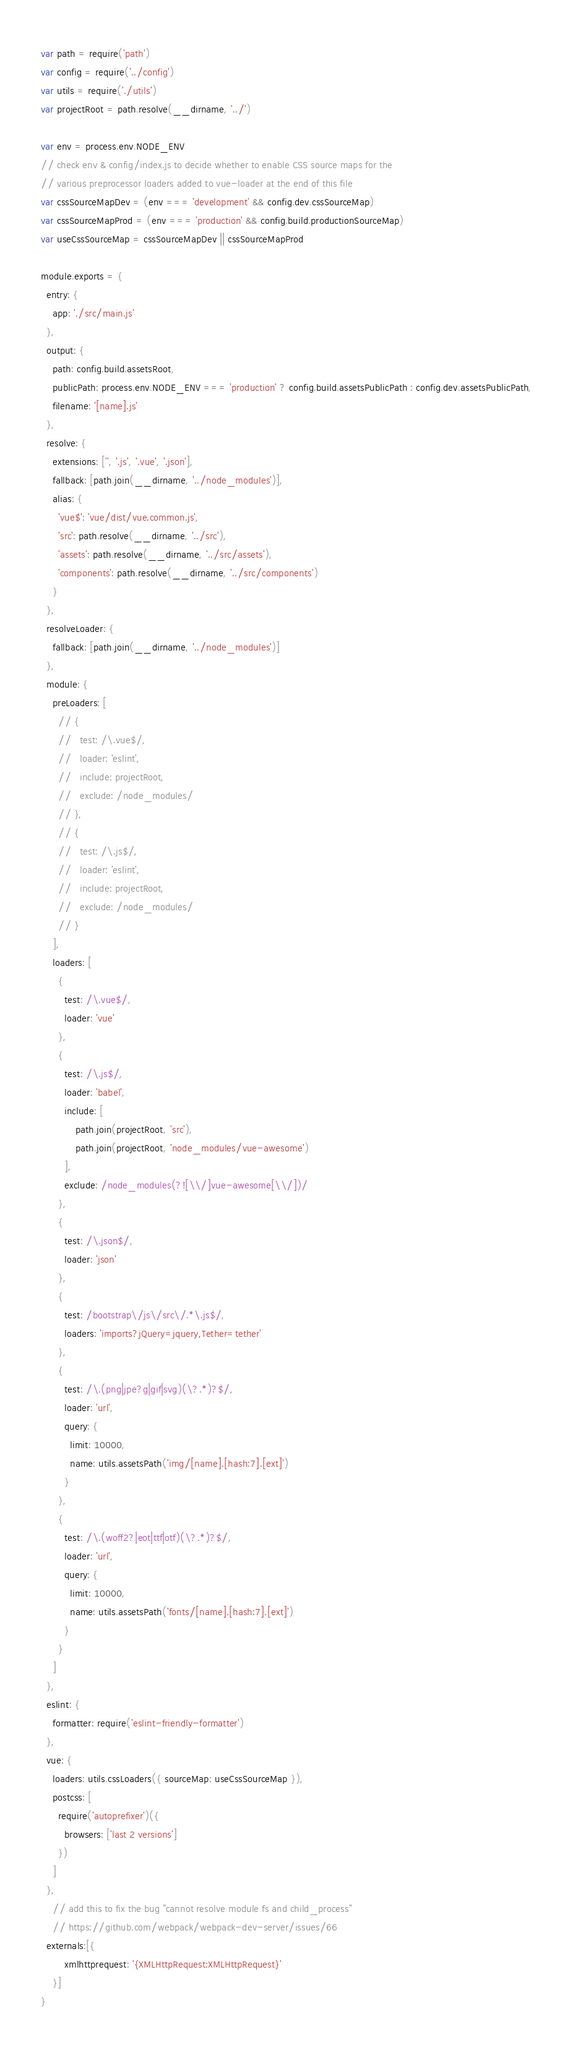Convert code to text. <code><loc_0><loc_0><loc_500><loc_500><_JavaScript_>var path = require('path')
var config = require('../config')
var utils = require('./utils')
var projectRoot = path.resolve(__dirname, '../')

var env = process.env.NODE_ENV
// check env & config/index.js to decide whether to enable CSS source maps for the
// various preprocessor loaders added to vue-loader at the end of this file
var cssSourceMapDev = (env === 'development' && config.dev.cssSourceMap)
var cssSourceMapProd = (env === 'production' && config.build.productionSourceMap)
var useCssSourceMap = cssSourceMapDev || cssSourceMapProd

module.exports = {
  entry: {
    app: './src/main.js'
  },
  output: {
    path: config.build.assetsRoot,
    publicPath: process.env.NODE_ENV === 'production' ? config.build.assetsPublicPath : config.dev.assetsPublicPath,
    filename: '[name].js'
  },
  resolve: {
    extensions: ['', '.js', '.vue', '.json'],
    fallback: [path.join(__dirname, '../node_modules')],
    alias: {
      'vue$': 'vue/dist/vue.common.js',
      'src': path.resolve(__dirname, '../src'),
      'assets': path.resolve(__dirname, '../src/assets'),
      'components': path.resolve(__dirname, '../src/components')
    }
  },
  resolveLoader: {
    fallback: [path.join(__dirname, '../node_modules')]
  },
  module: {
    preLoaders: [
      // {
      //   test: /\.vue$/,
      //   loader: 'eslint',
      //   include: projectRoot,
      //   exclude: /node_modules/
      // },
      // {
      //   test: /\.js$/,
      //   loader: 'eslint',
      //   include: projectRoot,
      //   exclude: /node_modules/
      // }
    ],
    loaders: [
      {
        test: /\.vue$/,
        loader: 'vue'
      },
      {
        test: /\.js$/,
        loader: 'babel',
        include: [
            path.join(projectRoot, 'src'),
            path.join(projectRoot, 'node_modules/vue-awesome')
        ],
        exclude: /node_modules(?![\\/]vue-awesome[\\/])/
      },
      {
        test: /\.json$/,
        loader: 'json'
      },
      {
        test: /bootstrap\/js\/src\/.*\.js$/,
        loaders: 'imports?jQuery=jquery,Tether=tether'
      },
      {
        test: /\.(png|jpe?g|gif|svg)(\?.*)?$/,
        loader: 'url',
        query: {
          limit: 10000,
          name: utils.assetsPath('img/[name].[hash:7].[ext]')
        }
      },
      {
        test: /\.(woff2?|eot|ttf|otf)(\?.*)?$/,
        loader: 'url',
        query: {
          limit: 10000,
          name: utils.assetsPath('fonts/[name].[hash:7].[ext]')
        }
      }
    ]
  },
  eslint: {
    formatter: require('eslint-friendly-formatter')
  },
  vue: {
    loaders: utils.cssLoaders({ sourceMap: useCssSourceMap }),
    postcss: [
      require('autoprefixer')({
        browsers: ['last 2 versions']
      })
    ]
  },
    // add this to fix the bug "cannot resolve module fs and child_process"
    // https://github.com/webpack/webpack-dev-server/issues/66
  externals:[{
        xmlhttprequest: '{XMLHttpRequest:XMLHttpRequest}'
    }]
}
</code> 